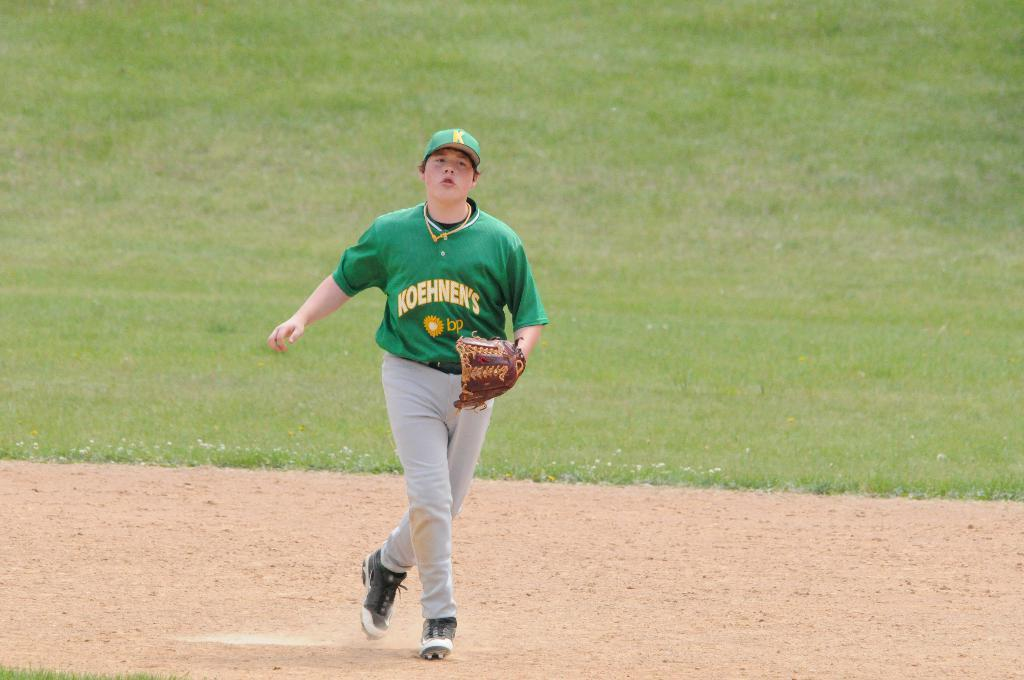What can be seen in the image that is meant for children's recreation? There is a playground in the image. Is there anyone present in the image? Yes, there is a person standing in the image. What is the person holding in the image? The person is holding a glove. What color is the t-shirt the person is wearing? The person is wearing a green color t-shirt. What type of headwear is the person wearing? The person is wearing a hat. What riddle does the person in the image pose to the viewer? There is no riddle posed by the person in the image; they are simply standing and holding a glove. 